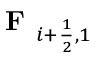Convert formula to latex. <formula><loc_0><loc_0><loc_500><loc_500>F _ { i + \frac { 1 } { 2 } , 1 }</formula> 